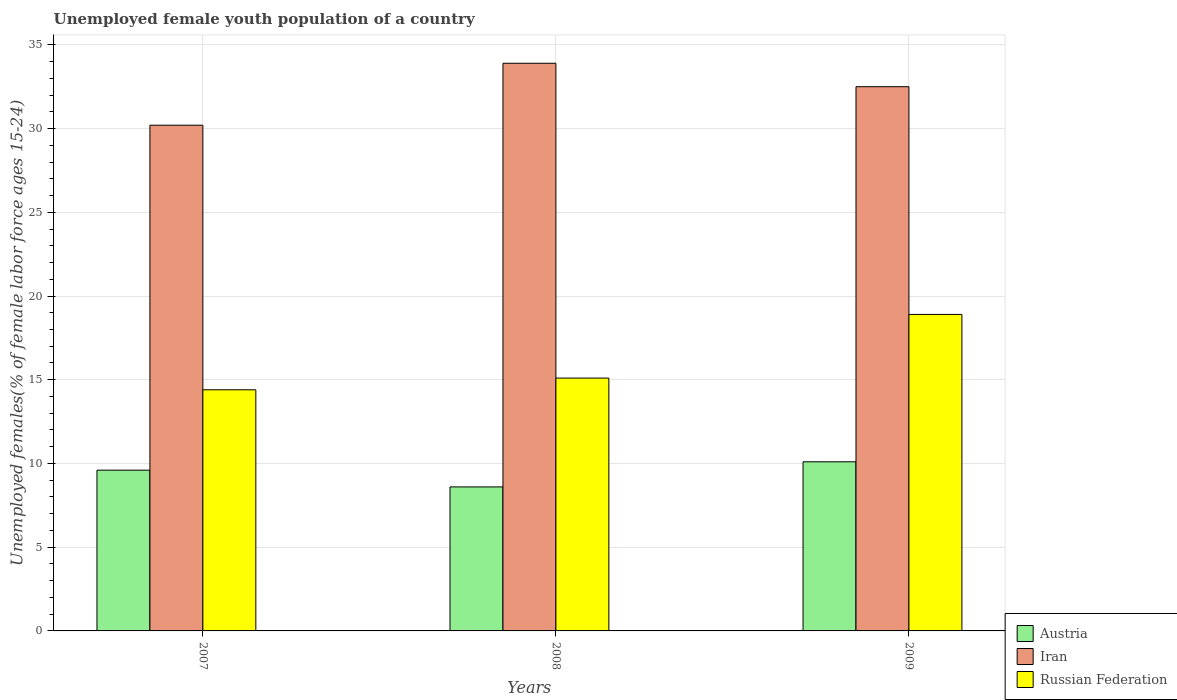How many different coloured bars are there?
Give a very brief answer. 3. Are the number of bars per tick equal to the number of legend labels?
Keep it short and to the point. Yes. Are the number of bars on each tick of the X-axis equal?
Offer a terse response. Yes. How many bars are there on the 2nd tick from the left?
Ensure brevity in your answer.  3. What is the percentage of unemployed female youth population in Iran in 2007?
Your answer should be very brief. 30.2. Across all years, what is the maximum percentage of unemployed female youth population in Austria?
Give a very brief answer. 10.1. Across all years, what is the minimum percentage of unemployed female youth population in Russian Federation?
Your response must be concise. 14.4. In which year was the percentage of unemployed female youth population in Iran maximum?
Keep it short and to the point. 2008. In which year was the percentage of unemployed female youth population in Austria minimum?
Provide a short and direct response. 2008. What is the total percentage of unemployed female youth population in Russian Federation in the graph?
Ensure brevity in your answer.  48.4. What is the difference between the percentage of unemployed female youth population in Russian Federation in 2007 and the percentage of unemployed female youth population in Iran in 2009?
Your answer should be compact. -18.1. What is the average percentage of unemployed female youth population in Iran per year?
Provide a succinct answer. 32.2. In the year 2008, what is the difference between the percentage of unemployed female youth population in Austria and percentage of unemployed female youth population in Iran?
Your answer should be compact. -25.3. What is the ratio of the percentage of unemployed female youth population in Iran in 2008 to that in 2009?
Your answer should be very brief. 1.04. What is the difference between the highest and the second highest percentage of unemployed female youth population in Austria?
Provide a short and direct response. 0.5. What is the difference between the highest and the lowest percentage of unemployed female youth population in Iran?
Offer a very short reply. 3.7. Is the sum of the percentage of unemployed female youth population in Austria in 2008 and 2009 greater than the maximum percentage of unemployed female youth population in Russian Federation across all years?
Your answer should be very brief. No. What does the 1st bar from the right in 2009 represents?
Keep it short and to the point. Russian Federation. Are all the bars in the graph horizontal?
Ensure brevity in your answer.  No. How many years are there in the graph?
Provide a short and direct response. 3. Does the graph contain any zero values?
Make the answer very short. No. How are the legend labels stacked?
Keep it short and to the point. Vertical. What is the title of the graph?
Offer a terse response. Unemployed female youth population of a country. What is the label or title of the Y-axis?
Keep it short and to the point. Unemployed females(% of female labor force ages 15-24). What is the Unemployed females(% of female labor force ages 15-24) in Austria in 2007?
Provide a short and direct response. 9.6. What is the Unemployed females(% of female labor force ages 15-24) of Iran in 2007?
Provide a short and direct response. 30.2. What is the Unemployed females(% of female labor force ages 15-24) of Russian Federation in 2007?
Your response must be concise. 14.4. What is the Unemployed females(% of female labor force ages 15-24) in Austria in 2008?
Your answer should be compact. 8.6. What is the Unemployed females(% of female labor force ages 15-24) in Iran in 2008?
Keep it short and to the point. 33.9. What is the Unemployed females(% of female labor force ages 15-24) in Russian Federation in 2008?
Keep it short and to the point. 15.1. What is the Unemployed females(% of female labor force ages 15-24) in Austria in 2009?
Your answer should be very brief. 10.1. What is the Unemployed females(% of female labor force ages 15-24) of Iran in 2009?
Your response must be concise. 32.5. What is the Unemployed females(% of female labor force ages 15-24) in Russian Federation in 2009?
Keep it short and to the point. 18.9. Across all years, what is the maximum Unemployed females(% of female labor force ages 15-24) in Austria?
Keep it short and to the point. 10.1. Across all years, what is the maximum Unemployed females(% of female labor force ages 15-24) of Iran?
Provide a short and direct response. 33.9. Across all years, what is the maximum Unemployed females(% of female labor force ages 15-24) of Russian Federation?
Give a very brief answer. 18.9. Across all years, what is the minimum Unemployed females(% of female labor force ages 15-24) of Austria?
Offer a terse response. 8.6. Across all years, what is the minimum Unemployed females(% of female labor force ages 15-24) in Iran?
Your answer should be very brief. 30.2. Across all years, what is the minimum Unemployed females(% of female labor force ages 15-24) in Russian Federation?
Provide a short and direct response. 14.4. What is the total Unemployed females(% of female labor force ages 15-24) in Austria in the graph?
Keep it short and to the point. 28.3. What is the total Unemployed females(% of female labor force ages 15-24) of Iran in the graph?
Your response must be concise. 96.6. What is the total Unemployed females(% of female labor force ages 15-24) in Russian Federation in the graph?
Give a very brief answer. 48.4. What is the difference between the Unemployed females(% of female labor force ages 15-24) in Austria in 2007 and that in 2008?
Keep it short and to the point. 1. What is the difference between the Unemployed females(% of female labor force ages 15-24) of Iran in 2007 and that in 2008?
Ensure brevity in your answer.  -3.7. What is the difference between the Unemployed females(% of female labor force ages 15-24) of Russian Federation in 2007 and that in 2008?
Provide a short and direct response. -0.7. What is the difference between the Unemployed females(% of female labor force ages 15-24) of Austria in 2007 and that in 2009?
Keep it short and to the point. -0.5. What is the difference between the Unemployed females(% of female labor force ages 15-24) of Iran in 2007 and that in 2009?
Keep it short and to the point. -2.3. What is the difference between the Unemployed females(% of female labor force ages 15-24) in Austria in 2008 and that in 2009?
Offer a terse response. -1.5. What is the difference between the Unemployed females(% of female labor force ages 15-24) in Austria in 2007 and the Unemployed females(% of female labor force ages 15-24) in Iran in 2008?
Give a very brief answer. -24.3. What is the difference between the Unemployed females(% of female labor force ages 15-24) in Iran in 2007 and the Unemployed females(% of female labor force ages 15-24) in Russian Federation in 2008?
Provide a short and direct response. 15.1. What is the difference between the Unemployed females(% of female labor force ages 15-24) in Austria in 2007 and the Unemployed females(% of female labor force ages 15-24) in Iran in 2009?
Your answer should be compact. -22.9. What is the difference between the Unemployed females(% of female labor force ages 15-24) of Austria in 2008 and the Unemployed females(% of female labor force ages 15-24) of Iran in 2009?
Offer a very short reply. -23.9. What is the average Unemployed females(% of female labor force ages 15-24) of Austria per year?
Ensure brevity in your answer.  9.43. What is the average Unemployed females(% of female labor force ages 15-24) in Iran per year?
Your answer should be very brief. 32.2. What is the average Unemployed females(% of female labor force ages 15-24) of Russian Federation per year?
Offer a terse response. 16.13. In the year 2007, what is the difference between the Unemployed females(% of female labor force ages 15-24) of Austria and Unemployed females(% of female labor force ages 15-24) of Iran?
Keep it short and to the point. -20.6. In the year 2007, what is the difference between the Unemployed females(% of female labor force ages 15-24) of Austria and Unemployed females(% of female labor force ages 15-24) of Russian Federation?
Ensure brevity in your answer.  -4.8. In the year 2008, what is the difference between the Unemployed females(% of female labor force ages 15-24) of Austria and Unemployed females(% of female labor force ages 15-24) of Iran?
Offer a very short reply. -25.3. In the year 2009, what is the difference between the Unemployed females(% of female labor force ages 15-24) of Austria and Unemployed females(% of female labor force ages 15-24) of Iran?
Your response must be concise. -22.4. What is the ratio of the Unemployed females(% of female labor force ages 15-24) of Austria in 2007 to that in 2008?
Your answer should be very brief. 1.12. What is the ratio of the Unemployed females(% of female labor force ages 15-24) of Iran in 2007 to that in 2008?
Your response must be concise. 0.89. What is the ratio of the Unemployed females(% of female labor force ages 15-24) in Russian Federation in 2007 to that in 2008?
Ensure brevity in your answer.  0.95. What is the ratio of the Unemployed females(% of female labor force ages 15-24) of Austria in 2007 to that in 2009?
Your answer should be compact. 0.95. What is the ratio of the Unemployed females(% of female labor force ages 15-24) in Iran in 2007 to that in 2009?
Provide a succinct answer. 0.93. What is the ratio of the Unemployed females(% of female labor force ages 15-24) in Russian Federation in 2007 to that in 2009?
Your answer should be compact. 0.76. What is the ratio of the Unemployed females(% of female labor force ages 15-24) of Austria in 2008 to that in 2009?
Your response must be concise. 0.85. What is the ratio of the Unemployed females(% of female labor force ages 15-24) of Iran in 2008 to that in 2009?
Your answer should be compact. 1.04. What is the ratio of the Unemployed females(% of female labor force ages 15-24) of Russian Federation in 2008 to that in 2009?
Provide a short and direct response. 0.8. What is the difference between the highest and the second highest Unemployed females(% of female labor force ages 15-24) in Austria?
Offer a very short reply. 0.5. What is the difference between the highest and the second highest Unemployed females(% of female labor force ages 15-24) in Iran?
Provide a succinct answer. 1.4. What is the difference between the highest and the second highest Unemployed females(% of female labor force ages 15-24) in Russian Federation?
Your answer should be very brief. 3.8. What is the difference between the highest and the lowest Unemployed females(% of female labor force ages 15-24) in Iran?
Your response must be concise. 3.7. 